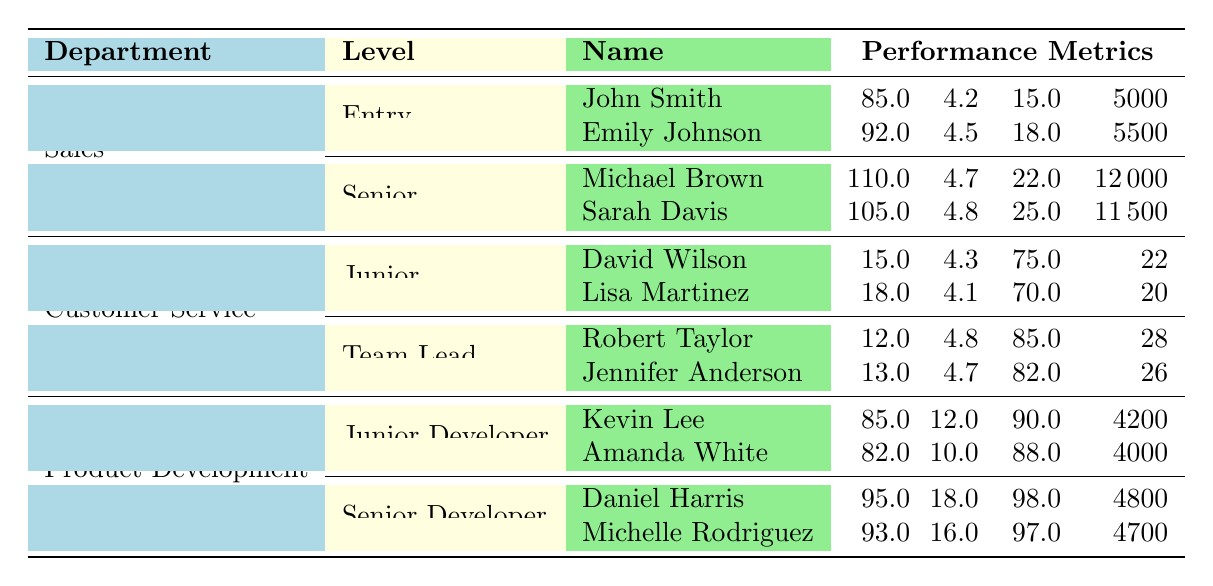What is the sales quota achievement of Emily Johnson? Emily Johnson's sales quota achievement is explicitly listed in the table under the Sales department, specifically in the Entry level section. The value for her sales quota achievement is 92.
Answer: 92 What is the customer satisfaction score of Robert Taylor? Robert Taylor's customer satisfaction score is found in the table under the Customer Service department, specifically in the Team Lead level section. His score is 4.8.
Answer: 4.8 Which employee has the highest average deal size in the Sales department? To determine this, we compare the average deal sizes of all employees in the Sales department, which are 5000 (John Smith), 5500 (Emily Johnson), 12000 (Michael Brown), and 11500 (Sarah Davis). Michael Brown has the highest average deal size of 12000.
Answer: Michael Brown What is the average customer satisfaction score of the Junior level employees in Customer Service? We take the customer satisfaction scores of the Junior employees (David Wilson and Lisa Martinez), which are 4.3 and 4.1 respectively. The average is calculated as (4.3 + 4.1) / 2 = 4.2.
Answer: 4.2 Which level in the Sales department has the highest lead conversion rate? The Entry level has lead conversion rates of 15 (John Smith) and 18 (Emily Johnson); the Senior level has rates of 22 (Michael Brown) and 25 (Sarah Davis). Comparing these, the Senior level has the highest lead conversion rate of 25 (Sarah Davis).
Answer: Senior Is there any employee in the Product Development department who has a code quality score above 90? Looking at the code quality scores in the Product Development department, Kevin Lee has 85, Amanda White has 82, Daniel Harris has 95, and Michelle Rodriguez has 93. Both Daniel Harris and Michelle Rodriguez have scores above 90. Therefore, the answer is yes.
Answer: Yes What is the total number of tickets resolved per day by team leads in Customer Service? We can sum the tickets resolved per day for the team leads: Robert Taylor resolves 28 tickets and Jennifer Anderson resolves 26 tickets. Summing these gives 28 + 26 = 54 tickets resolved per day in total.
Answer: 54 Which department and level does Daniel Harris belong to? Daniel Harris is listed in the Product Development department and is at the Senior Developer level, as seen in the table.
Answer: Product Development, Senior Developer What is the difference in average resolution time between Robert Taylor and Lisa Martinez? Robert Taylor has an average resolution time of 12 minutes, while Lisa Martinez has 18 minutes. To find the difference, we subtract 12 from 18, which equals 6 minutes.
Answer: 6 Is the first call resolution rate of Jennifer Anderson greater than that of David Wilson? Jennifer Anderson's first call resolution rate is 82, while David Wilson's is 75. Since 82 is greater than 75, the answer is yes.
Answer: Yes 